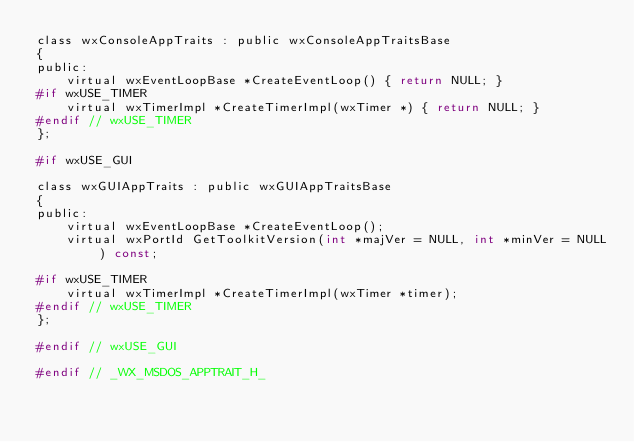Convert code to text. <code><loc_0><loc_0><loc_500><loc_500><_C_>class wxConsoleAppTraits : public wxConsoleAppTraitsBase
{
public:
    virtual wxEventLoopBase *CreateEventLoop() { return NULL; }
#if wxUSE_TIMER
    virtual wxTimerImpl *CreateTimerImpl(wxTimer *) { return NULL; }
#endif // wxUSE_TIMER
};

#if wxUSE_GUI

class wxGUIAppTraits : public wxGUIAppTraitsBase
{
public:
    virtual wxEventLoopBase *CreateEventLoop();
    virtual wxPortId GetToolkitVersion(int *majVer = NULL, int *minVer = NULL) const;

#if wxUSE_TIMER
    virtual wxTimerImpl *CreateTimerImpl(wxTimer *timer);
#endif // wxUSE_TIMER
};

#endif // wxUSE_GUI

#endif // _WX_MSDOS_APPTRAIT_H_
</code> 